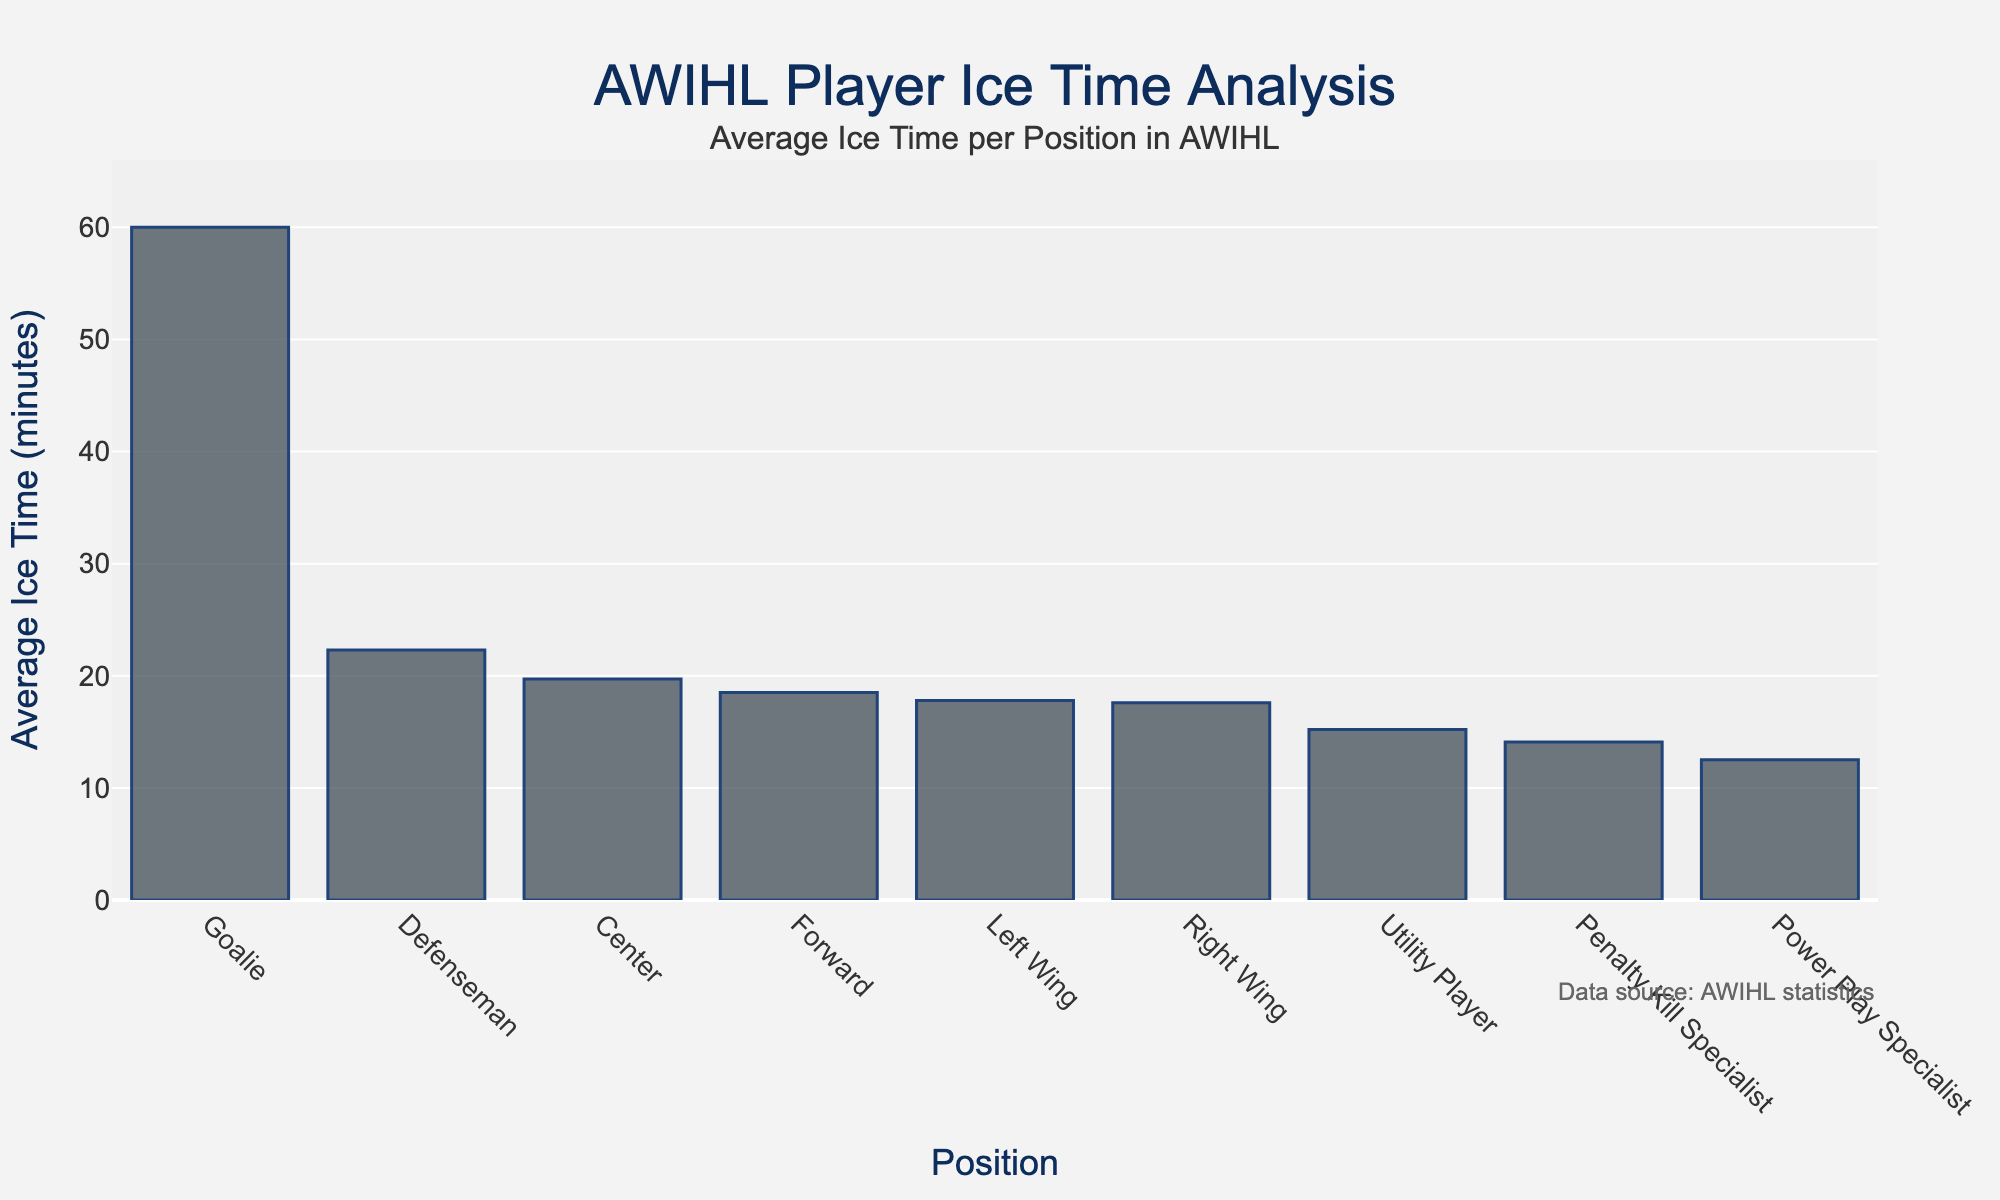What's the position with the highest average ice time? The position with the tallest bar in the chart represents the highest average ice time. The goalie position has the tallest bar.
Answer: Goalie Which position has the lowest average ice time? The position with the shortest bar in the chart represents the lowest average ice time. The Power Play Specialist position has the shortest bar.
Answer: Power Play Specialist How much more average ice time do defensemen get compared to forwards? Find the average ice time for defensemen and forwards, then subtract the average ice time of forwards from that of defensemen. Defensemen get 22.3 minutes, and forwards get 18.5 minutes. The difference is 22.3 - 18.5 = 3.8 minutes.
Answer: 3.8 minutes What is the total average ice time for Center, Left Wing, and Right Wing positions? Sum the average ice times for Center (19.7), Left Wing (17.8), and Right Wing (17.6). The total is 19.7 + 17.8 + 17.6 = 55.1 minutes.
Answer: 55.1 minutes Is the average ice time of the Utility Player greater than that of the Penalty Kill Specialist? Compare the bar heights of the Utility Player (15.2 minutes) and Penalty Kill Specialist (14.1 minutes). The Utility Player's bar is taller, indicating a higher average ice time.
Answer: Yes Which position has an average ice time closest to 15 minutes? Locate the bar closest to the 15-minute mark on the y-axis. The Utility Player position has an average ice time of 15.2 minutes, which is closest to 15 minutes.
Answer: Utility Player How does the average ice time of forwards compare to that of centers? Compare the bar heights of forwards (18.5 minutes) and centers (19.7 minutes). The center position has a taller bar, indicating a higher average ice time.
Answer: Centers have more ice time What is the difference in average ice time between the Goalie and the average of all other positions combined? First, find the average ice time for all non-goalie positions, add their times and divide by the number of positions. Then subtract this average from the goalie's ice time. Non-goalie positions: (18.5 + 22.3 + 19.7 + 17.8 + 17.6 + 15.2 + 12.5 + 14.1) / 8 = 17.46 minutes. The difference is 60.0 - 17.46 = 42.54 minutes.
Answer: 42.54 minutes Which has a higher average ice time, Power Play Specialist or Penalty Kill Specialist? Compare the bar heights of Power Play Specialist (12.5 minutes) and Penalty Kill Specialist (14.1 minutes). The Penalty Kill Specialist's bar is taller, indicating a higher average ice time.
Answer: Penalty Kill Specialist What is the combined average ice time for the Forward, Utility Player, and Left Wing positions? Sum the average ice times for Forward (18.5), Utility Player (15.2), and Left Wing (17.8). The total is 18.5 + 15.2 + 17.8 = 51.5 minutes.
Answer: 51.5 minutes 